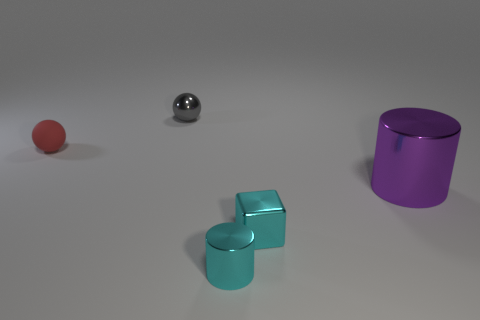What color is the tiny shiny sphere that is left of the large purple shiny cylinder?
Your answer should be very brief. Gray. Are there more things that are in front of the big purple shiny cylinder than green matte spheres?
Ensure brevity in your answer.  Yes. What number of other objects are the same size as the matte object?
Keep it short and to the point. 3. What number of large purple shiny cylinders are on the right side of the cyan metal block?
Your answer should be compact. 1. Are there the same number of small red objects behind the tiny red thing and matte things to the right of the cyan metal block?
Ensure brevity in your answer.  Yes. The thing that is behind the red object has what shape?
Offer a very short reply. Sphere. Do the object that is to the right of the small cyan shiny cube and the thing that is behind the red thing have the same material?
Give a very brief answer. Yes. What shape is the small gray metallic thing?
Give a very brief answer. Sphere. Is the number of shiny blocks that are left of the gray shiny ball the same as the number of brown matte objects?
Keep it short and to the point. Yes. The metallic cylinder that is the same color as the small cube is what size?
Offer a terse response. Small. 